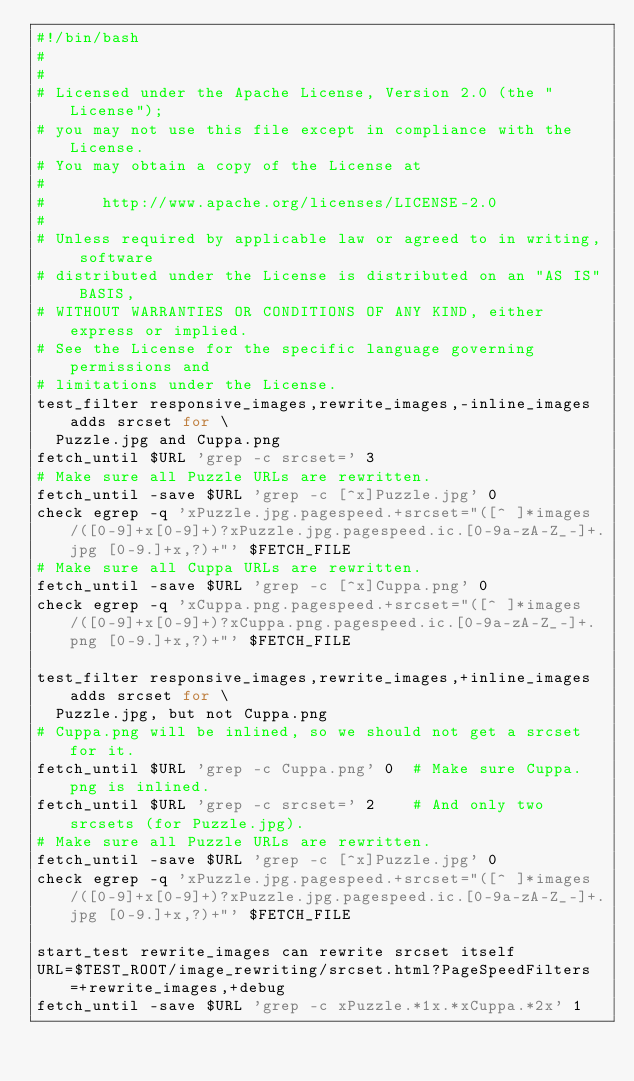Convert code to text. <code><loc_0><loc_0><loc_500><loc_500><_Bash_>#!/bin/bash
#
#
# Licensed under the Apache License, Version 2.0 (the "License");
# you may not use this file except in compliance with the License.
# You may obtain a copy of the License at
#
#      http://www.apache.org/licenses/LICENSE-2.0
#
# Unless required by applicable law or agreed to in writing, software
# distributed under the License is distributed on an "AS IS" BASIS,
# WITHOUT WARRANTIES OR CONDITIONS OF ANY KIND, either express or implied.
# See the License for the specific language governing permissions and
# limitations under the License.
test_filter responsive_images,rewrite_images,-inline_images adds srcset for \
  Puzzle.jpg and Cuppa.png
fetch_until $URL 'grep -c srcset=' 3
# Make sure all Puzzle URLs are rewritten.
fetch_until -save $URL 'grep -c [^x]Puzzle.jpg' 0
check egrep -q 'xPuzzle.jpg.pagespeed.+srcset="([^ ]*images/([0-9]+x[0-9]+)?xPuzzle.jpg.pagespeed.ic.[0-9a-zA-Z_-]+.jpg [0-9.]+x,?)+"' $FETCH_FILE
# Make sure all Cuppa URLs are rewritten.
fetch_until -save $URL 'grep -c [^x]Cuppa.png' 0
check egrep -q 'xCuppa.png.pagespeed.+srcset="([^ ]*images/([0-9]+x[0-9]+)?xCuppa.png.pagespeed.ic.[0-9a-zA-Z_-]+.png [0-9.]+x,?)+"' $FETCH_FILE

test_filter responsive_images,rewrite_images,+inline_images adds srcset for \
  Puzzle.jpg, but not Cuppa.png
# Cuppa.png will be inlined, so we should not get a srcset for it.
fetch_until $URL 'grep -c Cuppa.png' 0  # Make sure Cuppa.png is inlined.
fetch_until $URL 'grep -c srcset=' 2    # And only two srcsets (for Puzzle.jpg).
# Make sure all Puzzle URLs are rewritten.
fetch_until -save $URL 'grep -c [^x]Puzzle.jpg' 0
check egrep -q 'xPuzzle.jpg.pagespeed.+srcset="([^ ]*images/([0-9]+x[0-9]+)?xPuzzle.jpg.pagespeed.ic.[0-9a-zA-Z_-]+.jpg [0-9.]+x,?)+"' $FETCH_FILE

start_test rewrite_images can rewrite srcset itself
URL=$TEST_ROOT/image_rewriting/srcset.html?PageSpeedFilters=+rewrite_images,+debug
fetch_until -save $URL 'grep -c xPuzzle.*1x.*xCuppa.*2x' 1


</code> 